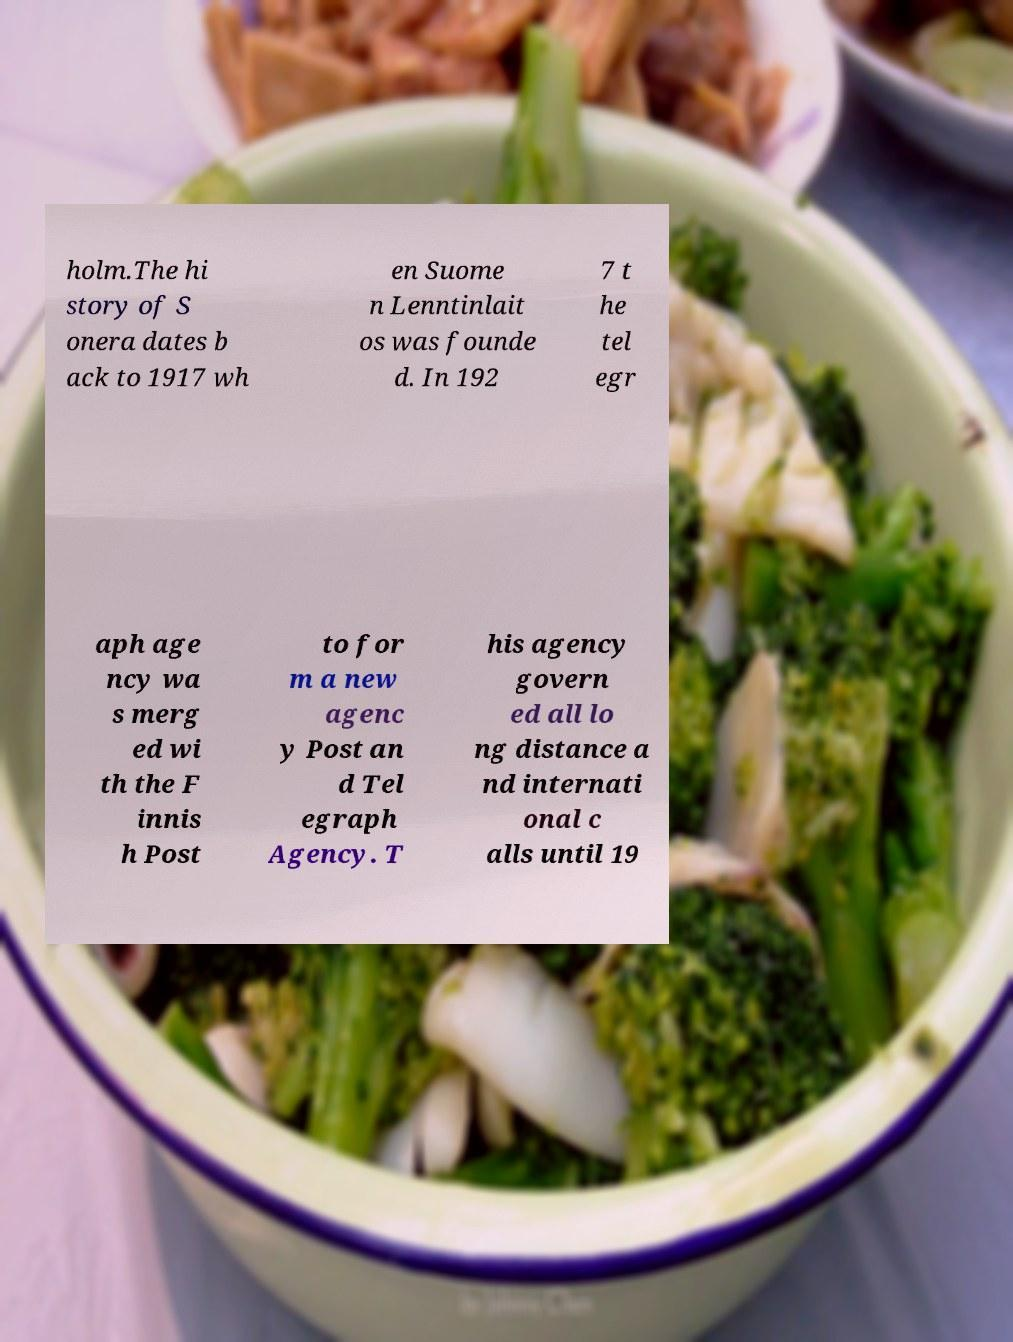Please read and relay the text visible in this image. What does it say? holm.The hi story of S onera dates b ack to 1917 wh en Suome n Lenntinlait os was founde d. In 192 7 t he tel egr aph age ncy wa s merg ed wi th the F innis h Post to for m a new agenc y Post an d Tel egraph Agency. T his agency govern ed all lo ng distance a nd internati onal c alls until 19 